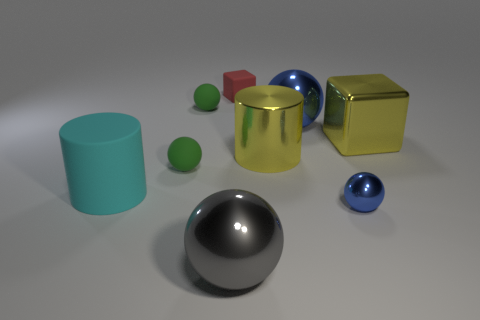What is the color of the metallic cube that is the same size as the gray sphere?
Make the answer very short. Yellow. What number of gray metallic things are left of the big yellow block?
Provide a short and direct response. 1. Are there any big blue shiny balls?
Give a very brief answer. Yes. How big is the green sphere that is to the left of the tiny matte ball behind the large cylinder that is to the right of the gray shiny object?
Give a very brief answer. Small. What number of other objects are there of the same size as the red thing?
Provide a succinct answer. 3. What is the size of the blue thing that is behind the cyan cylinder?
Offer a very short reply. Large. Is there anything else of the same color as the small rubber block?
Provide a short and direct response. No. Is the large yellow thing on the right side of the yellow cylinder made of the same material as the tiny red object?
Offer a terse response. No. What number of metallic spheres are behind the big gray shiny thing and on the left side of the small red rubber object?
Provide a short and direct response. 0. There is a metallic cylinder in front of the blue thing behind the big yellow cylinder; what size is it?
Provide a short and direct response. Large. 